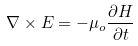Convert formula to latex. <formula><loc_0><loc_0><loc_500><loc_500>\nabla \times E = - \mu _ { o } \frac { \partial H } { \partial t }</formula> 